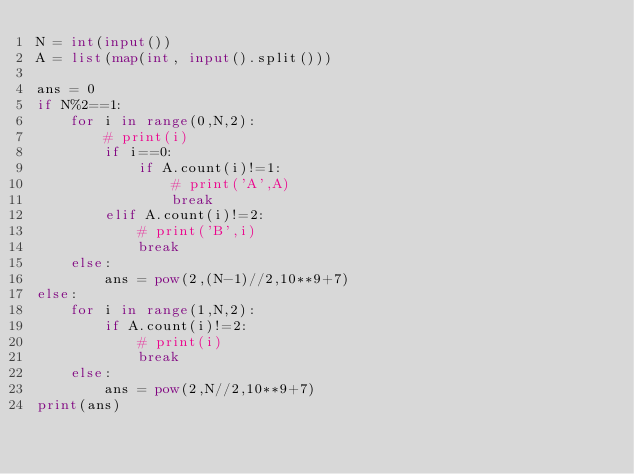<code> <loc_0><loc_0><loc_500><loc_500><_Python_>N = int(input())
A = list(map(int, input().split()))

ans = 0
if N%2==1:
    for i in range(0,N,2):
        # print(i)
        if i==0:
            if A.count(i)!=1:
                # print('A',A)
                break
        elif A.count(i)!=2:
            # print('B',i)
            break
    else:
        ans = pow(2,(N-1)//2,10**9+7)
else:
    for i in range(1,N,2):
        if A.count(i)!=2:
            # print(i)
            break
    else:
        ans = pow(2,N//2,10**9+7)
print(ans)</code> 